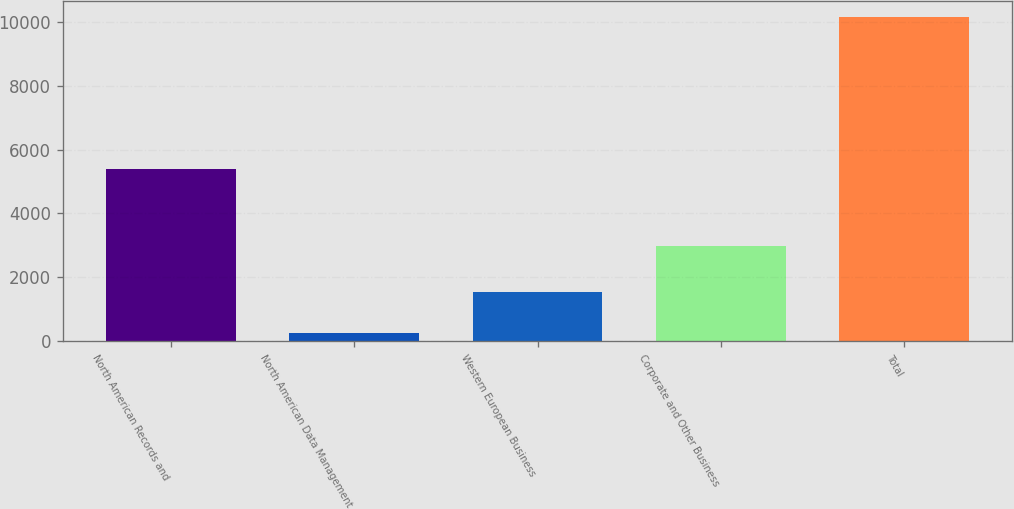Convert chart to OTSL. <chart><loc_0><loc_0><loc_500><loc_500><bar_chart><fcel>North American Records and<fcel>North American Data Management<fcel>Western European Business<fcel>Corporate and Other Business<fcel>Total<nl><fcel>5403<fcel>241<fcel>1537<fcel>2986<fcel>10167<nl></chart> 